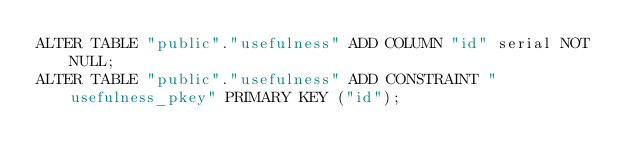Convert code to text. <code><loc_0><loc_0><loc_500><loc_500><_SQL_>ALTER TABLE "public"."usefulness" ADD COLUMN "id" serial NOT NULL;
ALTER TABLE "public"."usefulness" ADD CONSTRAINT "usefulness_pkey" PRIMARY KEY ("id");
</code> 